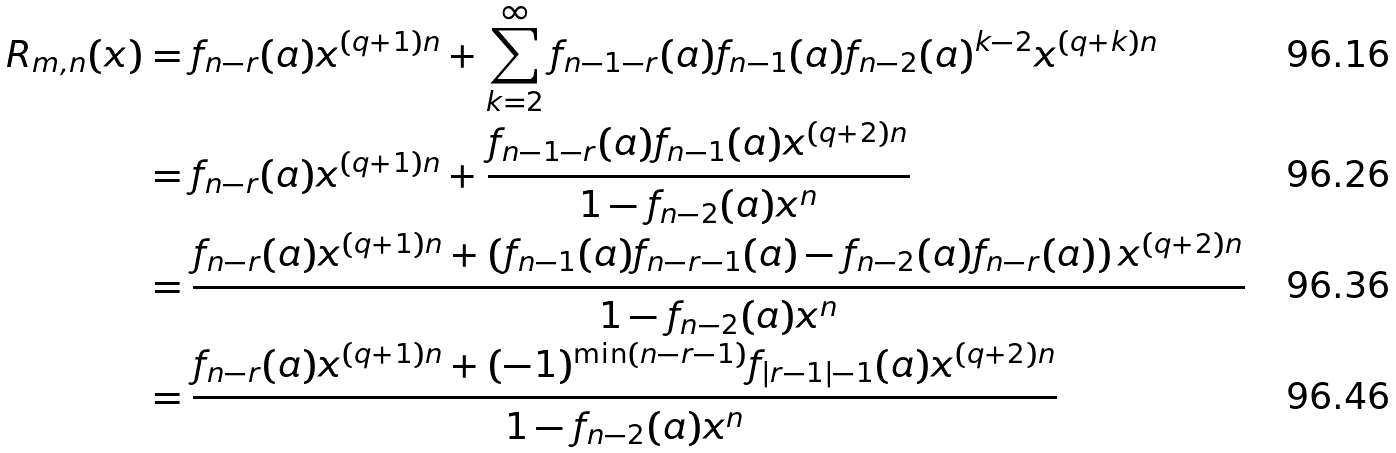<formula> <loc_0><loc_0><loc_500><loc_500>R _ { m , n } ( x ) & = f _ { n - r } ( a ) x ^ { ( q + 1 ) n } + \sum _ { k = 2 } ^ { \infty } f _ { n - 1 - r } ( a ) f _ { n - 1 } ( a ) f _ { n - 2 } ( a ) ^ { k - 2 } x ^ { ( q + k ) n } \\ & = f _ { n - r } ( a ) x ^ { ( q + 1 ) n } + \frac { f _ { n - 1 - r } ( a ) f _ { n - 1 } ( a ) x ^ { ( q + 2 ) n } } { 1 - f _ { n - 2 } ( a ) x ^ { n } } \\ & = \frac { f _ { n - r } ( a ) x ^ { ( q + 1 ) n } + \left ( f _ { n - 1 } ( a ) f _ { n - r - 1 } ( a ) - f _ { n - 2 } ( a ) f _ { n - r } ( a ) \right ) x ^ { ( q + 2 ) n } } { 1 - f _ { n - 2 } ( a ) x ^ { n } } \\ & = \frac { f _ { n - r } ( a ) x ^ { ( q + 1 ) n } + ( - 1 ) ^ { \min ( n - r - 1 ) } f _ { | r - 1 | - 1 } ( a ) x ^ { ( q + 2 ) n } } { 1 - f _ { n - 2 } ( a ) x ^ { n } }</formula> 